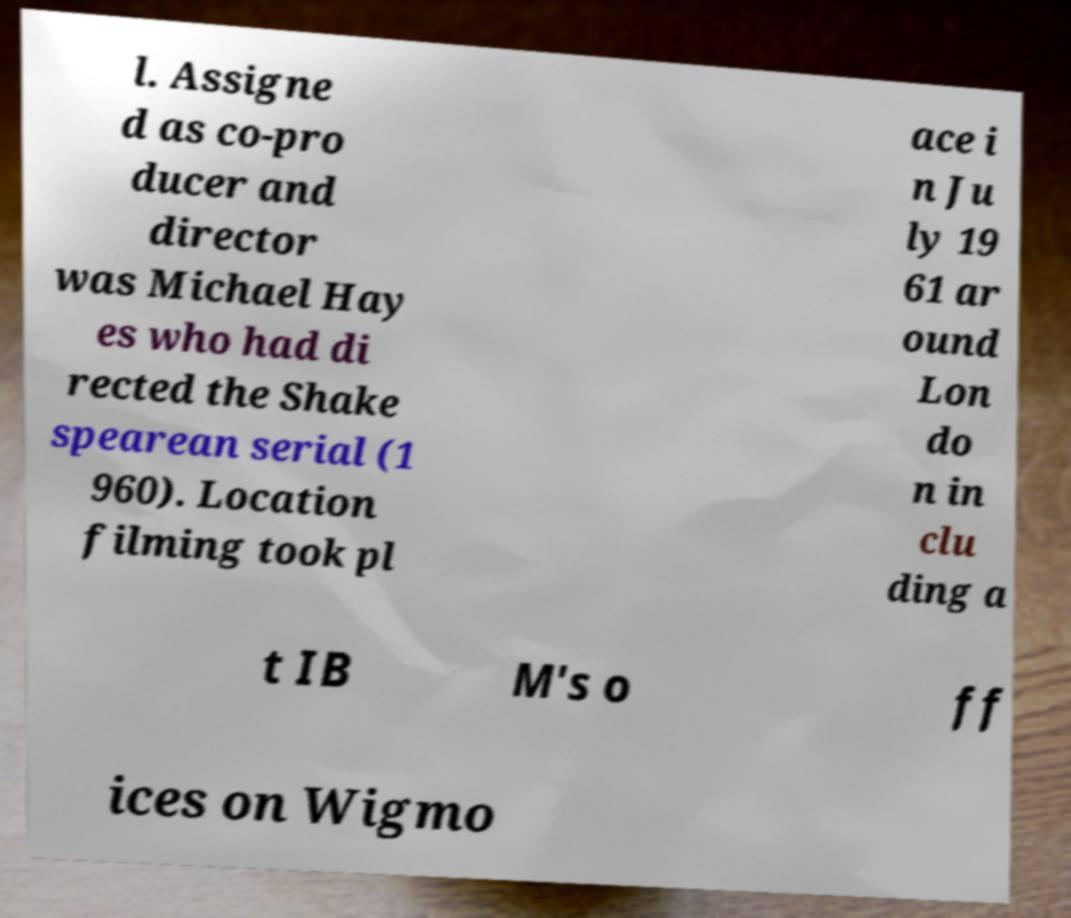Could you assist in decoding the text presented in this image and type it out clearly? l. Assigne d as co-pro ducer and director was Michael Hay es who had di rected the Shake spearean serial (1 960). Location filming took pl ace i n Ju ly 19 61 ar ound Lon do n in clu ding a t IB M's o ff ices on Wigmo 